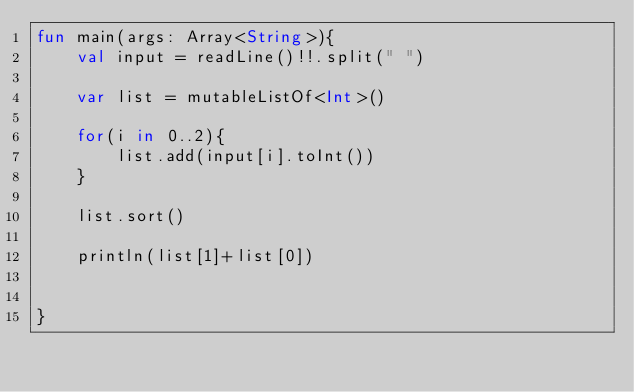<code> <loc_0><loc_0><loc_500><loc_500><_Kotlin_>fun main(args: Array<String>){
    val input = readLine()!!.split(" ")

    var list = mutableListOf<Int>()

    for(i in 0..2){
        list.add(input[i].toInt())
    }

    list.sort()

    println(list[1]+list[0])


}</code> 